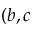Convert formula to latex. <formula><loc_0><loc_0><loc_500><loc_500>( b , c</formula> 